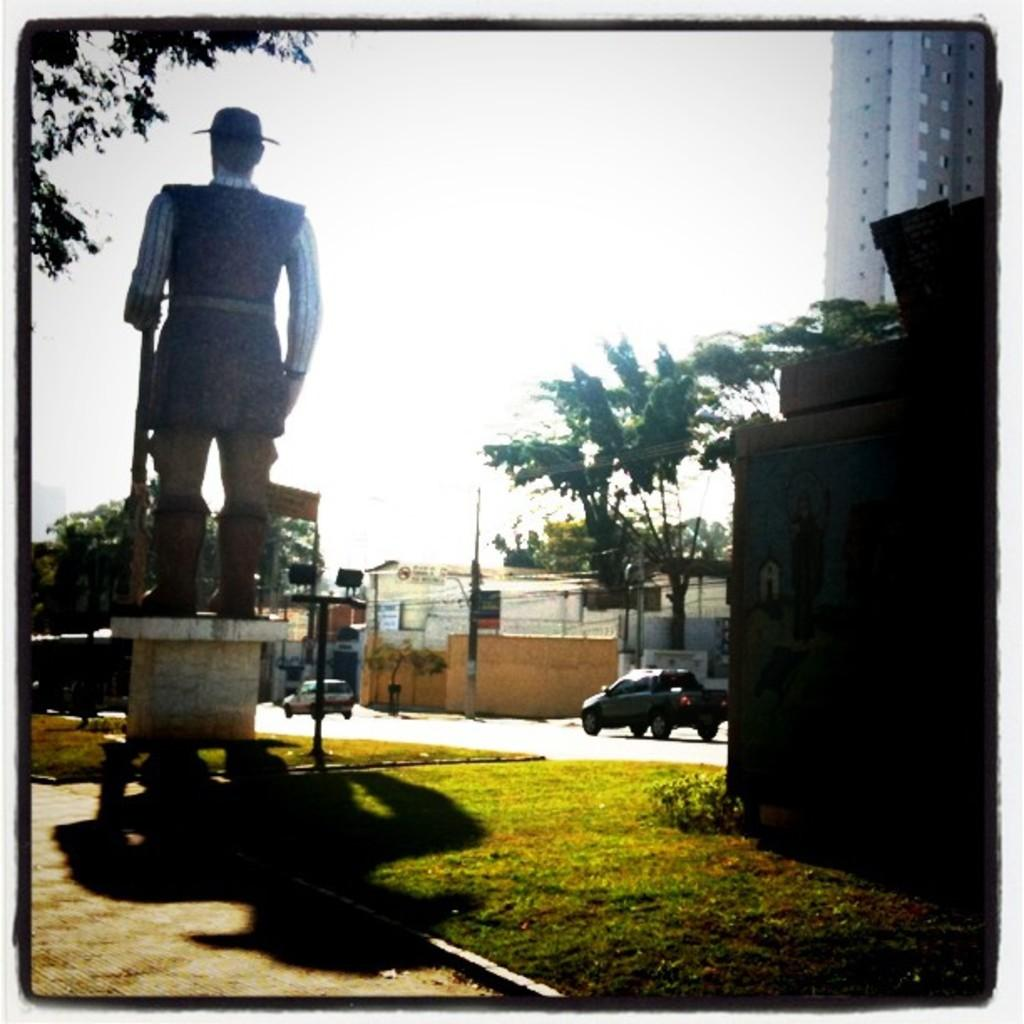What is the main subject of the image? There is a sculpture in the image. What type of natural elements can be seen in the image? There are trees, plants, grass, and the sky visible in the image. What type of man-made structures are present in the image? There are buildings and vehicles on the road in the image. Is there any text present in the image? Yes, there is a board with text in the image. What type of wine is being served at the event depicted in the image? There is no event or wine present in the image; it features a sculpture, natural elements, man-made structures, and a board with text. Can you describe the intricate details of the jelly in the image? There is no jelly present in the image. 